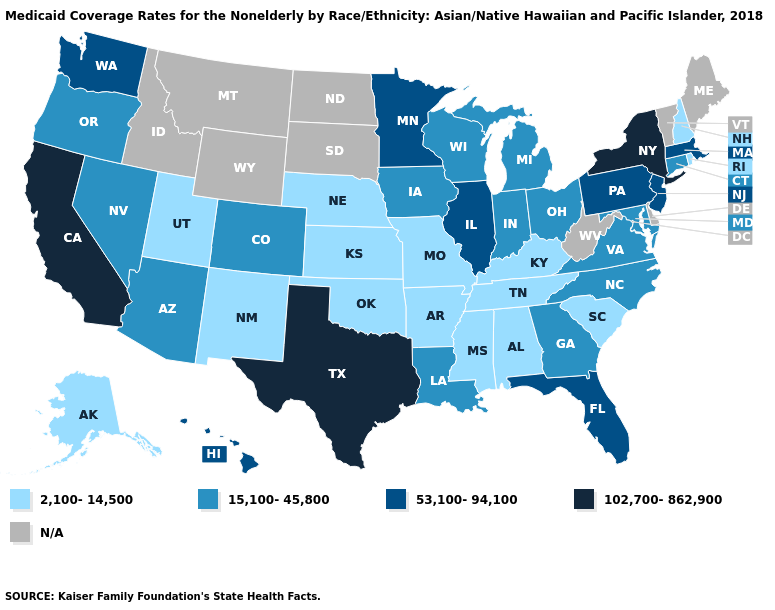What is the value of Vermont?
Write a very short answer. N/A. Does the first symbol in the legend represent the smallest category?
Write a very short answer. Yes. Name the states that have a value in the range N/A?
Be succinct. Delaware, Idaho, Maine, Montana, North Dakota, South Dakota, Vermont, West Virginia, Wyoming. What is the value of Wyoming?
Give a very brief answer. N/A. Does the first symbol in the legend represent the smallest category?
Write a very short answer. Yes. Does the map have missing data?
Quick response, please. Yes. Is the legend a continuous bar?
Be succinct. No. What is the lowest value in states that border Alabama?
Concise answer only. 2,100-14,500. What is the value of Oklahoma?
Be succinct. 2,100-14,500. What is the value of South Carolina?
Be succinct. 2,100-14,500. Which states have the lowest value in the Northeast?
Keep it brief. New Hampshire, Rhode Island. Name the states that have a value in the range 2,100-14,500?
Keep it brief. Alabama, Alaska, Arkansas, Kansas, Kentucky, Mississippi, Missouri, Nebraska, New Hampshire, New Mexico, Oklahoma, Rhode Island, South Carolina, Tennessee, Utah. How many symbols are there in the legend?
Answer briefly. 5. 